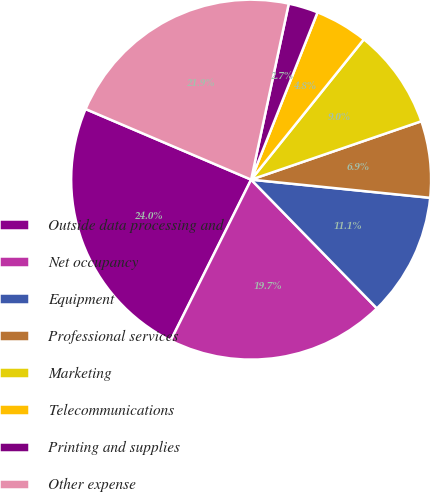Convert chart to OTSL. <chart><loc_0><loc_0><loc_500><loc_500><pie_chart><fcel>Outside data processing and<fcel>Net occupancy<fcel>Equipment<fcel>Professional services<fcel>Marketing<fcel>Telecommunications<fcel>Printing and supplies<fcel>Other expense<nl><fcel>24.04%<fcel>19.69%<fcel>11.08%<fcel>6.87%<fcel>8.97%<fcel>4.76%<fcel>2.66%<fcel>21.94%<nl></chart> 